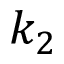Convert formula to latex. <formula><loc_0><loc_0><loc_500><loc_500>k _ { 2 }</formula> 